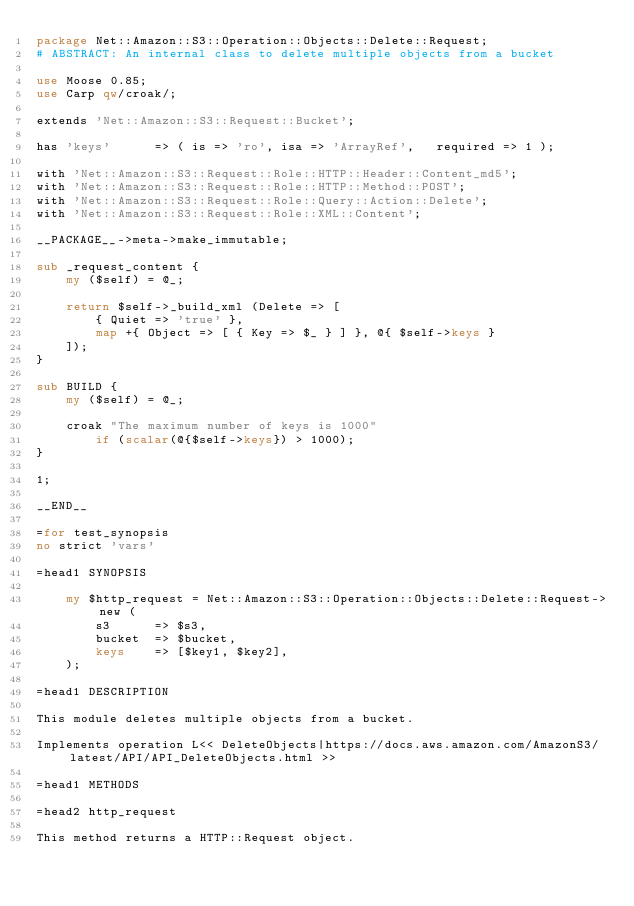<code> <loc_0><loc_0><loc_500><loc_500><_Perl_>package Net::Amazon::S3::Operation::Objects::Delete::Request;
# ABSTRACT: An internal class to delete multiple objects from a bucket

use Moose 0.85;
use Carp qw/croak/;

extends 'Net::Amazon::S3::Request::Bucket';

has 'keys'      => ( is => 'ro', isa => 'ArrayRef',   required => 1 );

with 'Net::Amazon::S3::Request::Role::HTTP::Header::Content_md5';
with 'Net::Amazon::S3::Request::Role::HTTP::Method::POST';
with 'Net::Amazon::S3::Request::Role::Query::Action::Delete';
with 'Net::Amazon::S3::Request::Role::XML::Content';

__PACKAGE__->meta->make_immutable;

sub _request_content {
	my ($self) = @_;

	return $self->_build_xml (Delete => [
		{ Quiet => 'true' },
		map +{ Object => [ { Key => $_ } ] }, @{ $self->keys }
	]);
}

sub BUILD {
	my ($self) = @_;

	croak "The maximum number of keys is 1000"
		if (scalar(@{$self->keys}) > 1000);
}

1;

__END__

=for test_synopsis
no strict 'vars'

=head1 SYNOPSIS

	my $http_request = Net::Amazon::S3::Operation::Objects::Delete::Request->new (
		s3      => $s3,
		bucket  => $bucket,
		keys    => [$key1, $key2],
	);

=head1 DESCRIPTION

This module deletes multiple objects from a bucket.

Implements operation L<< DeleteObjects|https://docs.aws.amazon.com/AmazonS3/latest/API/API_DeleteObjects.html >>

=head1 METHODS

=head2 http_request

This method returns a HTTP::Request object.
</code> 